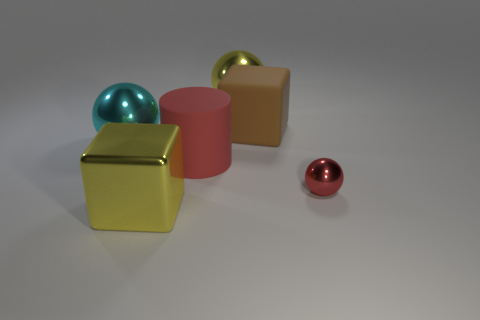There is a yellow metallic thing that is the same size as the yellow metal block; what is its shape?
Your response must be concise. Sphere. There is a metal ball that is in front of the red cylinder; what is its color?
Offer a terse response. Red. There is a large cube left of the yellow metallic sphere; are there any yellow spheres that are left of it?
Ensure brevity in your answer.  No. How many things are big metallic balls that are in front of the brown cube or large matte spheres?
Provide a succinct answer. 1. Are there any other things that are the same size as the red sphere?
Ensure brevity in your answer.  No. The large block behind the red object that is behind the red shiny object is made of what material?
Offer a very short reply. Rubber. Are there an equal number of big red objects that are right of the large metal block and blocks that are on the left side of the yellow metal ball?
Give a very brief answer. Yes. What number of things are either yellow objects that are in front of the brown matte thing or big yellow metallic things in front of the tiny metallic thing?
Your answer should be compact. 1. There is a sphere that is both right of the big cyan ball and behind the tiny shiny object; what material is it?
Give a very brief answer. Metal. There is a ball that is to the left of the large block that is on the left side of the big yellow thing behind the cyan thing; what is its size?
Make the answer very short. Large. 